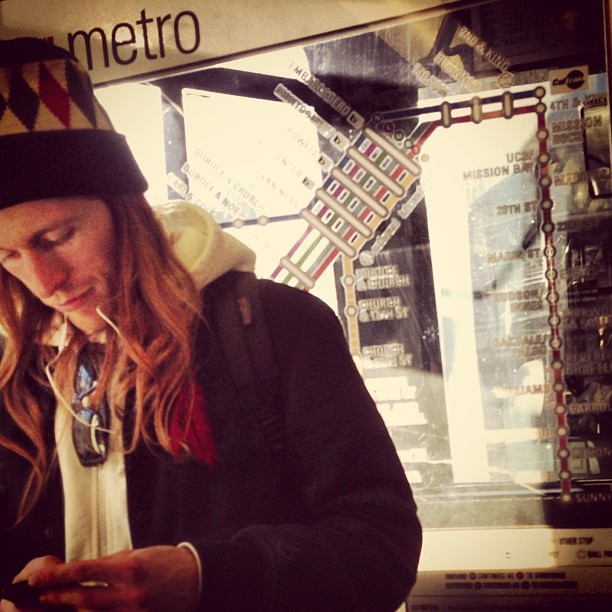Describe the objects in this image and their specific colors. I can see people in black, maroon, and brown tones and cell phone in maroon and black tones in this image. 